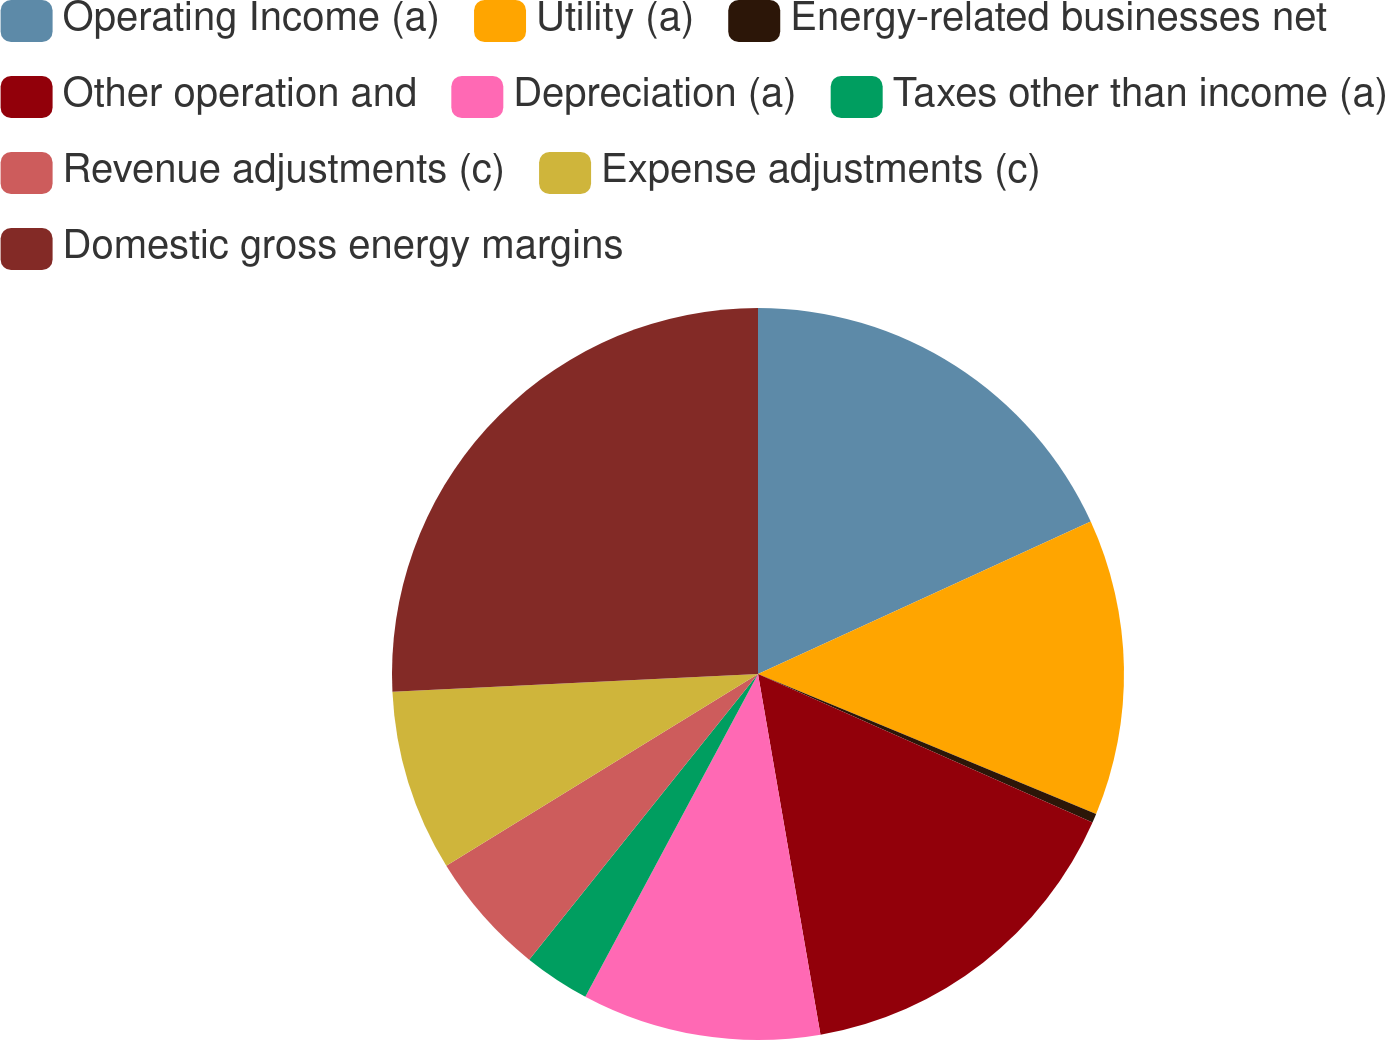Convert chart to OTSL. <chart><loc_0><loc_0><loc_500><loc_500><pie_chart><fcel>Operating Income (a)<fcel>Utility (a)<fcel>Energy-related businesses net<fcel>Other operation and<fcel>Depreciation (a)<fcel>Taxes other than income (a)<fcel>Revenue adjustments (c)<fcel>Expense adjustments (c)<fcel>Domestic gross energy margins<nl><fcel>18.16%<fcel>13.09%<fcel>0.4%<fcel>15.62%<fcel>10.55%<fcel>2.93%<fcel>5.47%<fcel>8.01%<fcel>25.77%<nl></chart> 